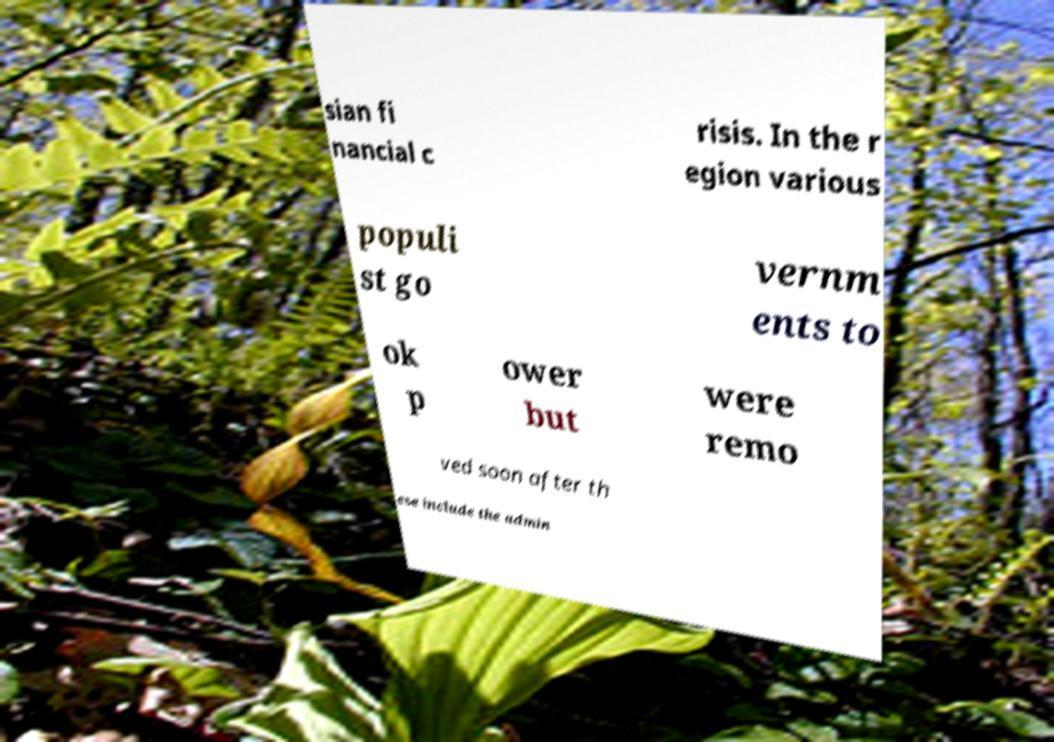For documentation purposes, I need the text within this image transcribed. Could you provide that? sian fi nancial c risis. In the r egion various populi st go vernm ents to ok p ower but were remo ved soon after th ese include the admin 